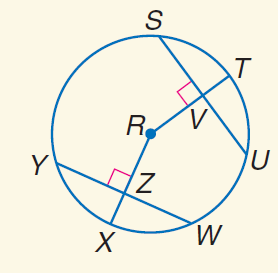Answer the mathemtical geometry problem and directly provide the correct option letter.
Question: Triangles F G H and F H J are inscribed in \odot K with \widehat F G \cong \widehat F I. Find x if m \angle 1 = 6 x - 5, and m \angle 2 = 7 x + 4.
Choices: A: 3 B: 7 C: 20 D: 30 B 